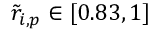Convert formula to latex. <formula><loc_0><loc_0><loc_500><loc_500>\tilde { r } _ { i , p } \in [ 0 . 8 3 , 1 ]</formula> 